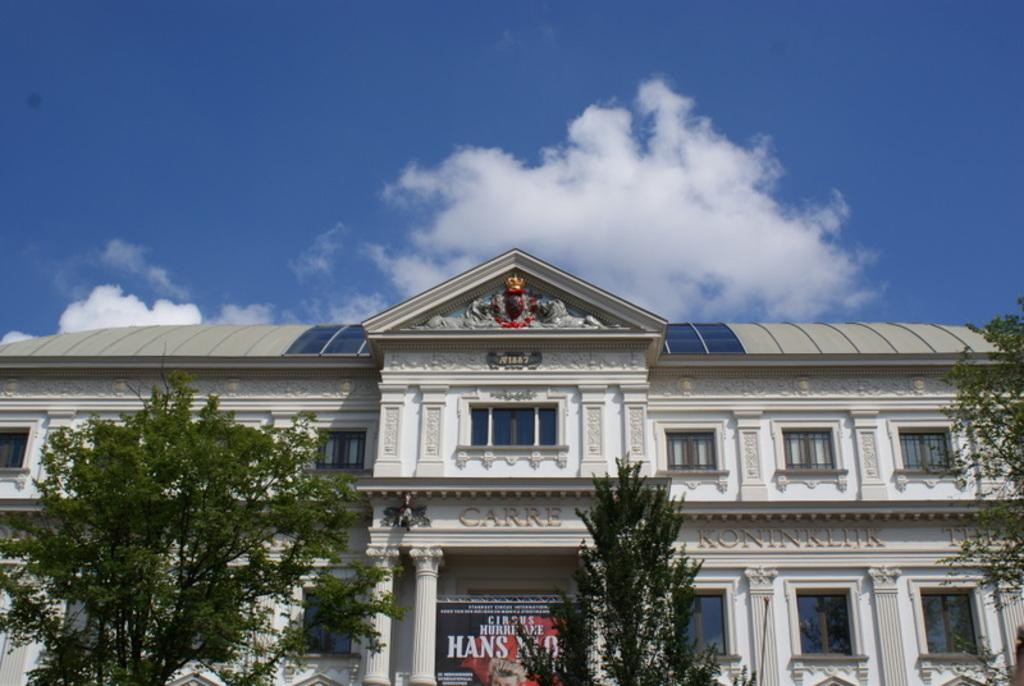What type of structure is present in the image? There is a building in the image. What other natural elements can be seen in the image? There are trees in the image. Is there any text or information displayed in the image? Yes, there is a board with writing on it in the image. What can be seen in the background of the image? The sky is visible in the background of the image. How many beggars are visible in the image? There are no beggars present in the image. What color is the eye of the person in the image? There is no person or eye visible in the image. 